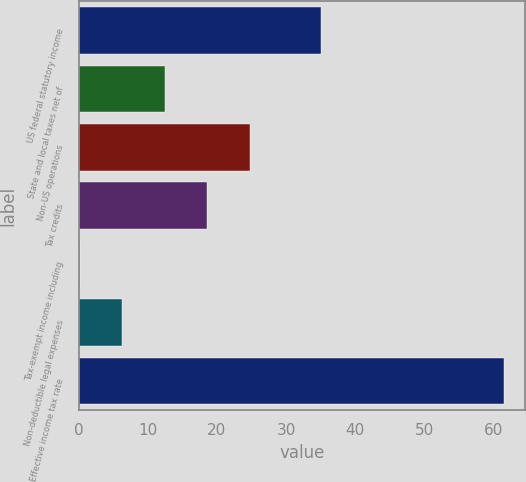<chart> <loc_0><loc_0><loc_500><loc_500><bar_chart><fcel>US federal statutory income<fcel>State and local taxes net of<fcel>Non-US operations<fcel>Tax credits<fcel>Tax-exempt income including<fcel>Non-deductible legal expenses<fcel>Effective income tax rate<nl><fcel>35<fcel>12.46<fcel>24.72<fcel>18.59<fcel>0.2<fcel>6.33<fcel>61.5<nl></chart> 